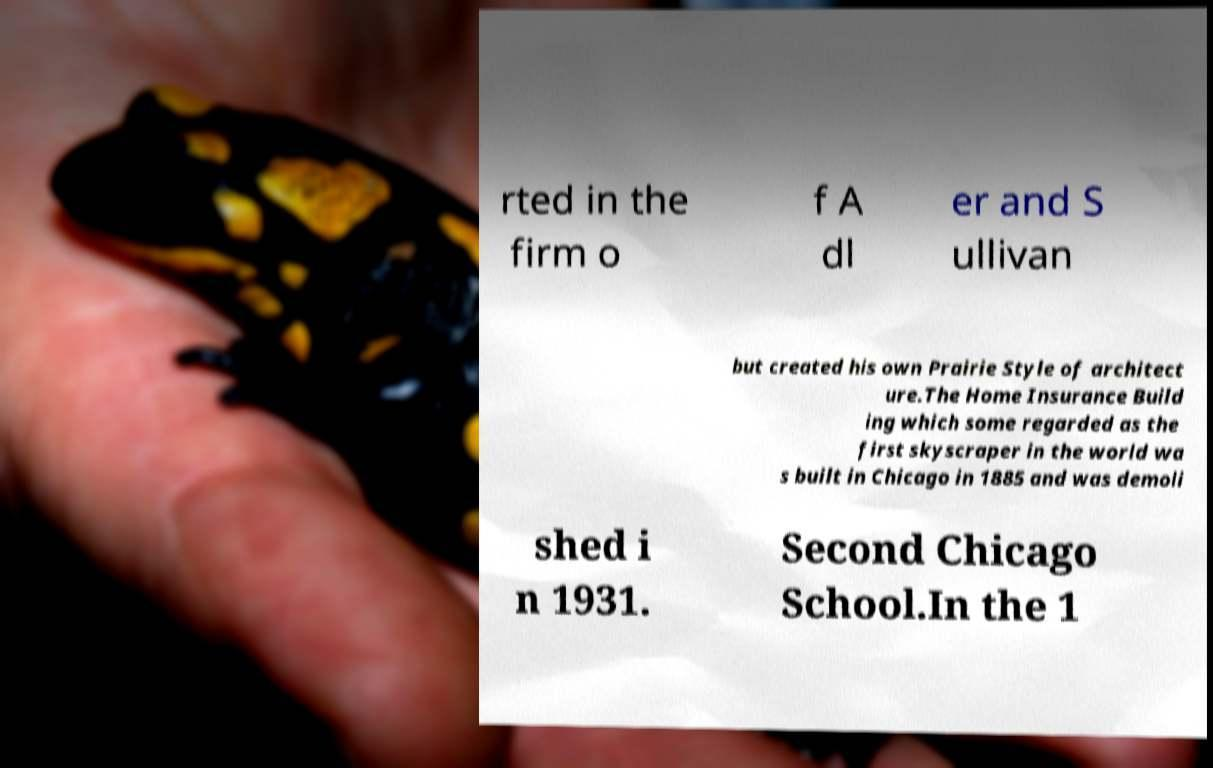Please identify and transcribe the text found in this image. rted in the firm o f A dl er and S ullivan but created his own Prairie Style of architect ure.The Home Insurance Build ing which some regarded as the first skyscraper in the world wa s built in Chicago in 1885 and was demoli shed i n 1931. Second Chicago School.In the 1 